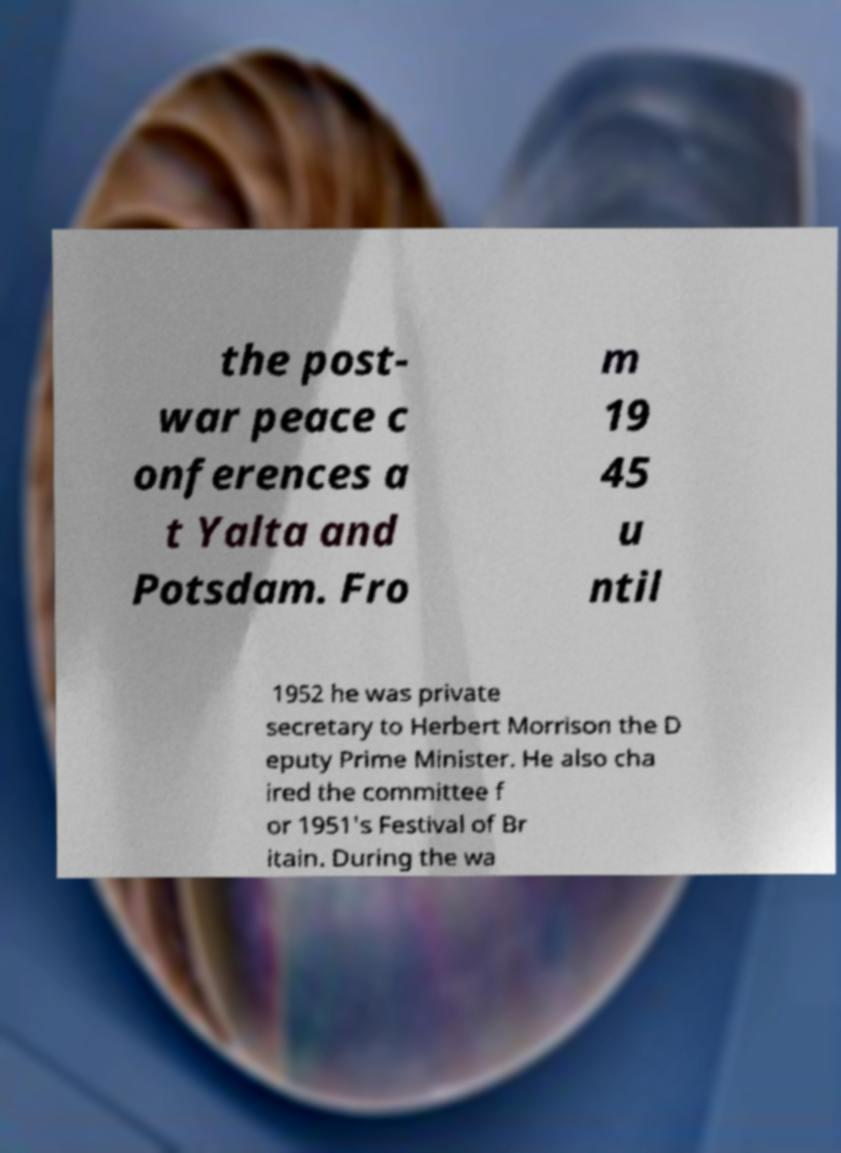I need the written content from this picture converted into text. Can you do that? the post- war peace c onferences a t Yalta and Potsdam. Fro m 19 45 u ntil 1952 he was private secretary to Herbert Morrison the D eputy Prime Minister. He also cha ired the committee f or 1951's Festival of Br itain. During the wa 